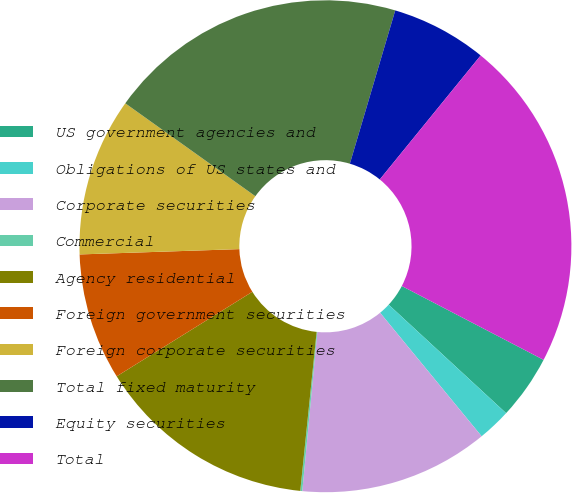Convert chart to OTSL. <chart><loc_0><loc_0><loc_500><loc_500><pie_chart><fcel>US government agencies and<fcel>Obligations of US states and<fcel>Corporate securities<fcel>Commercial<fcel>Agency residential<fcel>Foreign government securities<fcel>Foreign corporate securities<fcel>Total fixed maturity<fcel>Equity securities<fcel>Total<nl><fcel>4.23%<fcel>2.18%<fcel>12.45%<fcel>0.13%<fcel>14.5%<fcel>8.34%<fcel>10.4%<fcel>19.71%<fcel>6.29%<fcel>21.77%<nl></chart> 